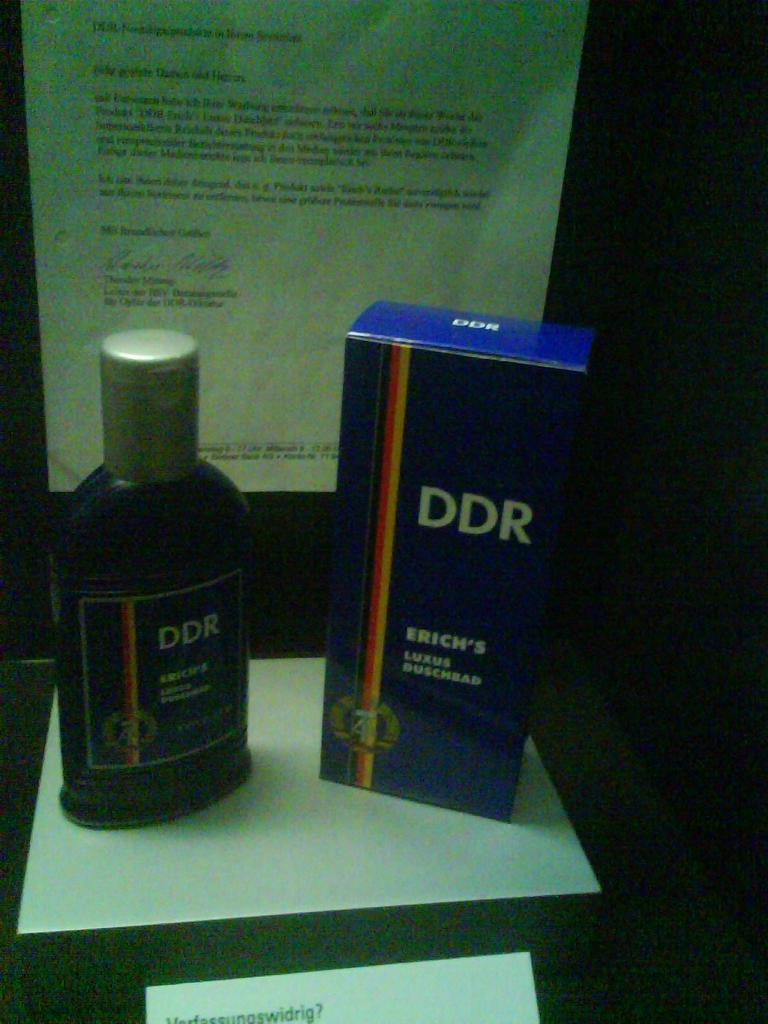What object can be seen in the image that typically contains a liquid? There is a bottle in the image that typically contains a liquid. What other object is present in the image? There is a box in the image. How is the box positioned in the image? The box is placed on a paper. What type of paper is present in the image? There is a paper with text in the image. Can you see the tongue of the person holding the bottle in the image? There is no person holding the bottle in the image, and therefore no tongue is visible. 